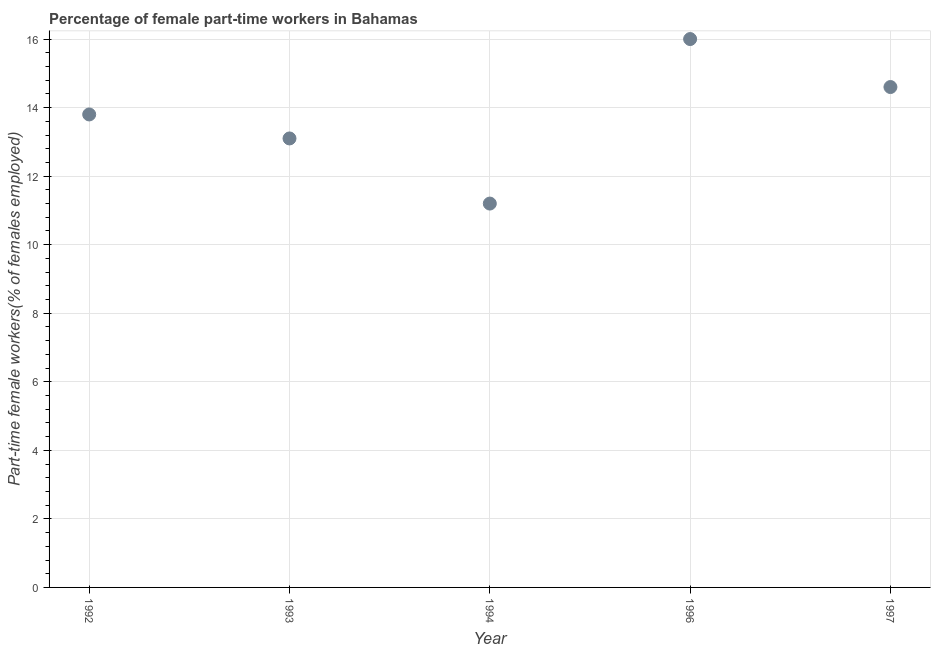What is the percentage of part-time female workers in 1993?
Make the answer very short. 13.1. Across all years, what is the minimum percentage of part-time female workers?
Offer a terse response. 11.2. In which year was the percentage of part-time female workers minimum?
Offer a very short reply. 1994. What is the sum of the percentage of part-time female workers?
Offer a very short reply. 68.7. What is the difference between the percentage of part-time female workers in 1992 and 1993?
Give a very brief answer. 0.7. What is the average percentage of part-time female workers per year?
Offer a terse response. 13.74. What is the median percentage of part-time female workers?
Give a very brief answer. 13.8. What is the ratio of the percentage of part-time female workers in 1992 to that in 1994?
Provide a short and direct response. 1.23. Is the difference between the percentage of part-time female workers in 1992 and 1994 greater than the difference between any two years?
Ensure brevity in your answer.  No. What is the difference between the highest and the second highest percentage of part-time female workers?
Give a very brief answer. 1.4. Is the sum of the percentage of part-time female workers in 1992 and 1993 greater than the maximum percentage of part-time female workers across all years?
Make the answer very short. Yes. What is the difference between the highest and the lowest percentage of part-time female workers?
Your answer should be compact. 4.8. How many years are there in the graph?
Provide a succinct answer. 5. Does the graph contain any zero values?
Keep it short and to the point. No. Does the graph contain grids?
Provide a succinct answer. Yes. What is the title of the graph?
Offer a very short reply. Percentage of female part-time workers in Bahamas. What is the label or title of the Y-axis?
Offer a very short reply. Part-time female workers(% of females employed). What is the Part-time female workers(% of females employed) in 1992?
Keep it short and to the point. 13.8. What is the Part-time female workers(% of females employed) in 1993?
Offer a very short reply. 13.1. What is the Part-time female workers(% of females employed) in 1994?
Your answer should be compact. 11.2. What is the Part-time female workers(% of females employed) in 1997?
Make the answer very short. 14.6. What is the difference between the Part-time female workers(% of females employed) in 1992 and 1994?
Your answer should be compact. 2.6. What is the difference between the Part-time female workers(% of females employed) in 1992 and 1997?
Your answer should be compact. -0.8. What is the difference between the Part-time female workers(% of females employed) in 1993 and 1994?
Your answer should be compact. 1.9. What is the difference between the Part-time female workers(% of females employed) in 1993 and 1996?
Provide a short and direct response. -2.9. What is the difference between the Part-time female workers(% of females employed) in 1994 and 1996?
Make the answer very short. -4.8. What is the difference between the Part-time female workers(% of females employed) in 1996 and 1997?
Offer a very short reply. 1.4. What is the ratio of the Part-time female workers(% of females employed) in 1992 to that in 1993?
Offer a very short reply. 1.05. What is the ratio of the Part-time female workers(% of females employed) in 1992 to that in 1994?
Offer a terse response. 1.23. What is the ratio of the Part-time female workers(% of females employed) in 1992 to that in 1996?
Provide a short and direct response. 0.86. What is the ratio of the Part-time female workers(% of females employed) in 1992 to that in 1997?
Your answer should be very brief. 0.94. What is the ratio of the Part-time female workers(% of females employed) in 1993 to that in 1994?
Your response must be concise. 1.17. What is the ratio of the Part-time female workers(% of females employed) in 1993 to that in 1996?
Your response must be concise. 0.82. What is the ratio of the Part-time female workers(% of females employed) in 1993 to that in 1997?
Your answer should be very brief. 0.9. What is the ratio of the Part-time female workers(% of females employed) in 1994 to that in 1997?
Offer a terse response. 0.77. What is the ratio of the Part-time female workers(% of females employed) in 1996 to that in 1997?
Your answer should be compact. 1.1. 